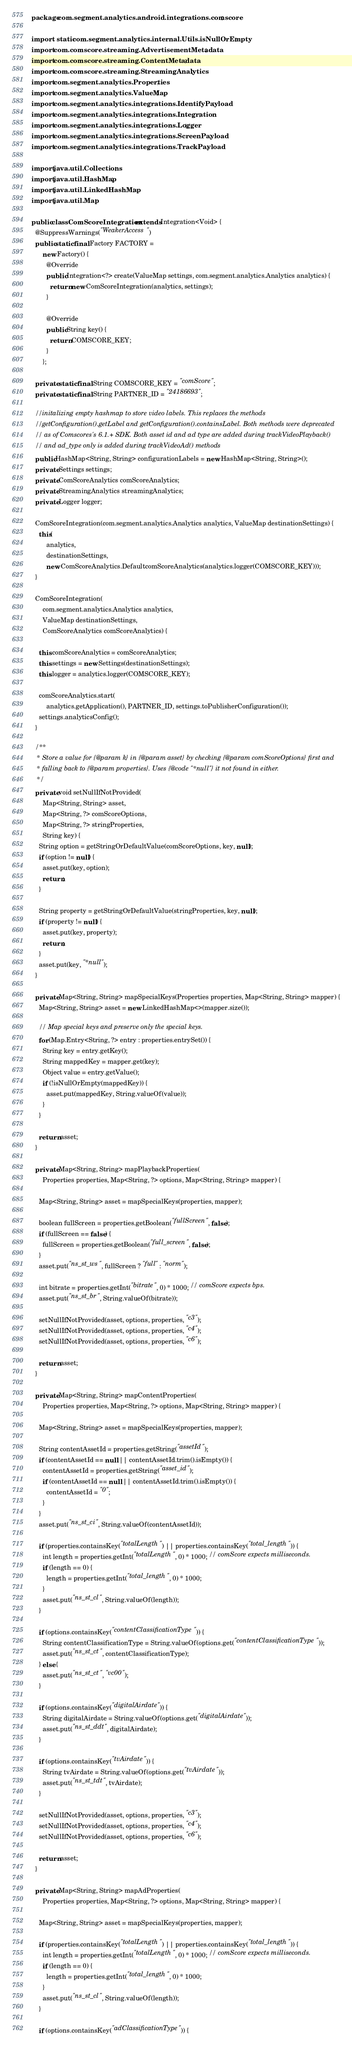Convert code to text. <code><loc_0><loc_0><loc_500><loc_500><_Java_>package com.segment.analytics.android.integrations.comscore;

import static com.segment.analytics.internal.Utils.isNullOrEmpty;
import com.comscore.streaming.AdvertisementMetadata;
import com.comscore.streaming.ContentMetadata;
import com.comscore.streaming.StreamingAnalytics;
import com.segment.analytics.Properties;
import com.segment.analytics.ValueMap;
import com.segment.analytics.integrations.IdentifyPayload;
import com.segment.analytics.integrations.Integration;
import com.segment.analytics.integrations.Logger;
import com.segment.analytics.integrations.ScreenPayload;
import com.segment.analytics.integrations.TrackPayload;

import java.util.Collections;
import java.util.HashMap;
import java.util.LinkedHashMap;
import java.util.Map;

public class ComScoreIntegration extends Integration<Void> {
  @SuppressWarnings("WeakerAccess")
  public static final Factory FACTORY =
      new Factory() {
        @Override
        public Integration<?> create(ValueMap settings, com.segment.analytics.Analytics analytics) {
          return new ComScoreIntegration(analytics, settings);
        }

        @Override
        public String key() {
          return COMSCORE_KEY;
        }
      };

  private static final String COMSCORE_KEY = "comScore";
  private static final String PARTNER_ID = "24186693";

  //initalizing empty hashmap to store video labels. This replaces the methods
  //getConfiguration().getLabel and getConfiguration().containsLabel. Both methods were deprecated
  // as of Comscores's 6.1.+ SDK. Both asset id and ad type are added during trackVideoPlayback()
  // and ad_type only is added during trackVideoAd() methods
  public HashMap<String, String> configurationLabels = new HashMap<String, String>();
  private Settings settings;
  private ComScoreAnalytics comScoreAnalytics;
  private StreamingAnalytics streamingAnalytics;
  private Logger logger;

  ComScoreIntegration(com.segment.analytics.Analytics analytics, ValueMap destinationSettings) {
    this(
        analytics,
        destinationSettings,
        new ComScoreAnalytics.DefaultcomScoreAnalytics(analytics.logger(COMSCORE_KEY)));
  }

  ComScoreIntegration(
      com.segment.analytics.Analytics analytics,
      ValueMap destinationSettings,
      ComScoreAnalytics comScoreAnalytics) {

    this.comScoreAnalytics = comScoreAnalytics;
    this.settings = new Settings(destinationSettings);
    this.logger = analytics.logger(COMSCORE_KEY);

    comScoreAnalytics.start(
        analytics.getApplication(), PARTNER_ID, settings.toPublisherConfiguration());
    settings.analyticsConfig();
  }

  /**
   * Store a value for {@param k} in {@param asset} by checking {@param comScoreOptions} first and
   * falling back to {@param properties}. Uses {@code "*null"} it not found in either.
   */
  private void setNullIfNotProvided(
      Map<String, String> asset,
      Map<String, ?> comScoreOptions,
      Map<String, ?> stringProperties,
      String key) {
    String option = getStringOrDefaultValue(comScoreOptions, key, null);
    if (option != null) {
      asset.put(key, option);
      return;
    }

    String property = getStringOrDefaultValue(stringProperties, key, null);
    if (property != null) {
      asset.put(key, property);
      return;
    }
    asset.put(key, "*null");
  }

  private Map<String, String> mapSpecialKeys(Properties properties, Map<String, String> mapper) {
    Map<String, String> asset = new LinkedHashMap<>(mapper.size());

    // Map special keys and preserve only the special keys.
    for (Map.Entry<String, ?> entry : properties.entrySet()) {
      String key = entry.getKey();
      String mappedKey = mapper.get(key);
      Object value = entry.getValue();
      if (!isNullOrEmpty(mappedKey)) {
        asset.put(mappedKey, String.valueOf(value));
      }
    }

    return asset;
  }

  private Map<String, String> mapPlaybackProperties(
      Properties properties, Map<String, ?> options, Map<String, String> mapper) {

    Map<String, String> asset = mapSpecialKeys(properties, mapper);

    boolean fullScreen = properties.getBoolean("fullScreen", false);
    if (fullScreen == false) {
      fullScreen = properties.getBoolean("full_screen", false);
    }
    asset.put("ns_st_ws", fullScreen ? "full" : "norm");

    int bitrate = properties.getInt("bitrate", 0) * 1000; // comScore expects bps.
    asset.put("ns_st_br", String.valueOf(bitrate));

    setNullIfNotProvided(asset, options, properties, "c3");
    setNullIfNotProvided(asset, options, properties, "c4");
    setNullIfNotProvided(asset, options, properties, "c6");

    return asset;
  }

  private Map<String, String> mapContentProperties(
      Properties properties, Map<String, ?> options, Map<String, String> mapper) {

    Map<String, String> asset = mapSpecialKeys(properties, mapper);

    String contentAssetId = properties.getString("assetId");
    if (contentAssetId == null || contentAssetId.trim().isEmpty()) {
      contentAssetId = properties.getString("asset_id");
      if (contentAssetId == null || contentAssetId.trim().isEmpty()) {
        contentAssetId = "0";
      }
    }
    asset.put("ns_st_ci", String.valueOf(contentAssetId));

    if (properties.containsKey("totalLength") || properties.containsKey("total_length")) {
      int length = properties.getInt("totalLength", 0) * 1000; // comScore expects milliseconds.
      if (length == 0) {
        length = properties.getInt("total_length", 0) * 1000;
      }
      asset.put("ns_st_cl", String.valueOf(length));
    }

    if (options.containsKey("contentClassificationType")) {
      String contentClassificationType = String.valueOf(options.get("contentClassificationType"));
      asset.put("ns_st_ct", contentClassificationType);
    } else {
      asset.put("ns_st_ct", "vc00");
    }

    if (options.containsKey("digitalAirdate")) {
      String digitalAirdate = String.valueOf(options.get("digitalAirdate"));
      asset.put("ns_st_ddt", digitalAirdate);
    }

    if (options.containsKey("tvAirdate")) {
      String tvAirdate = String.valueOf(options.get("tvAirdate"));
      asset.put("ns_st_tdt", tvAirdate);
    }

    setNullIfNotProvided(asset, options, properties, "c3");
    setNullIfNotProvided(asset, options, properties, "c4");
    setNullIfNotProvided(asset, options, properties, "c6");

    return asset;
  }

  private Map<String, String> mapAdProperties(
      Properties properties, Map<String, ?> options, Map<String, String> mapper) {

    Map<String, String> asset = mapSpecialKeys(properties, mapper);

    if (properties.containsKey("totalLength") || properties.containsKey("total_length")) {
      int length = properties.getInt("totalLength", 0) * 1000; // comScore expects milliseconds.
      if (length == 0) {
        length = properties.getInt("total_length", 0) * 1000;
      }
      asset.put("ns_st_cl", String.valueOf(length));
    }

    if (options.containsKey("adClassificationType")) {</code> 